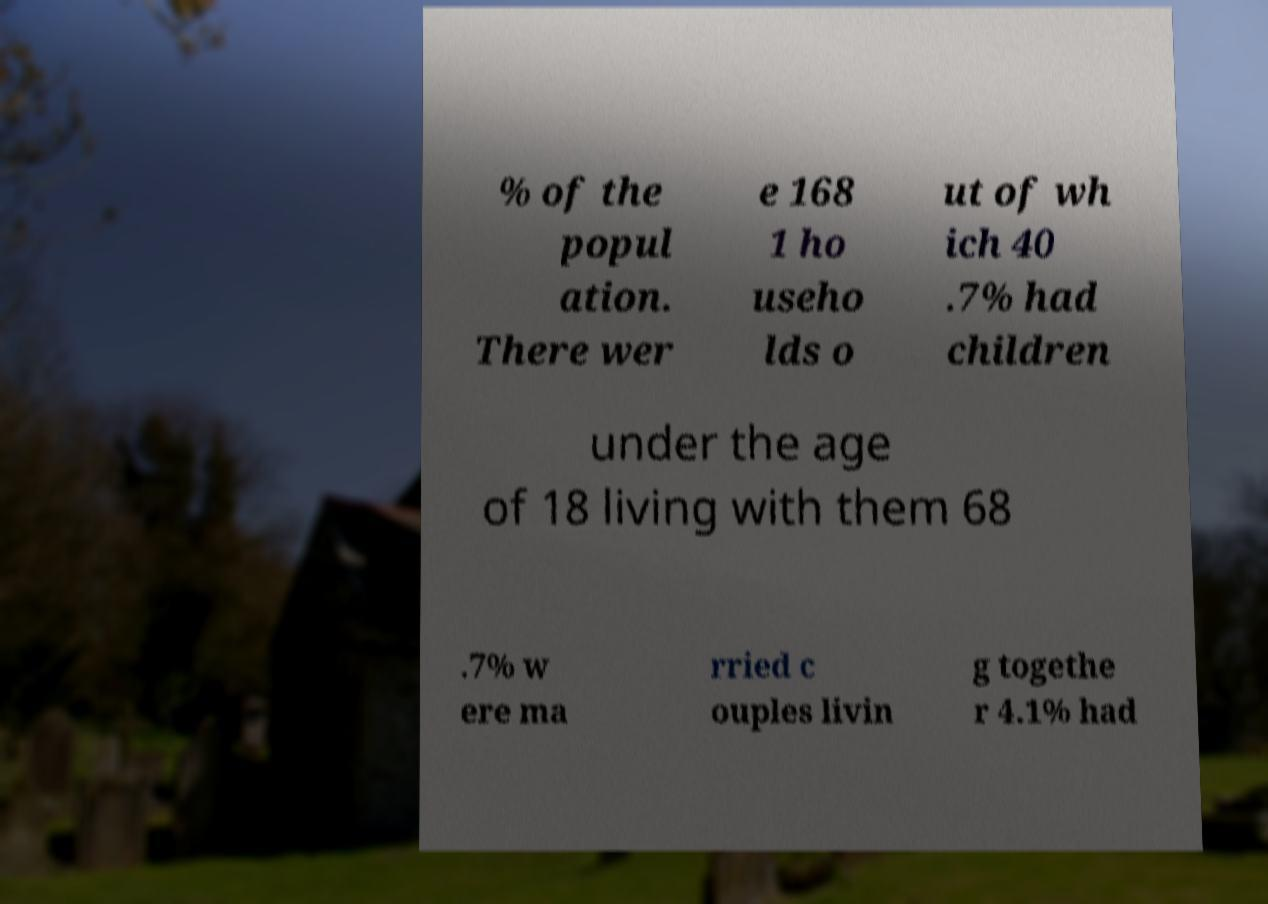Can you read and provide the text displayed in the image?This photo seems to have some interesting text. Can you extract and type it out for me? % of the popul ation. There wer e 168 1 ho useho lds o ut of wh ich 40 .7% had children under the age of 18 living with them 68 .7% w ere ma rried c ouples livin g togethe r 4.1% had 